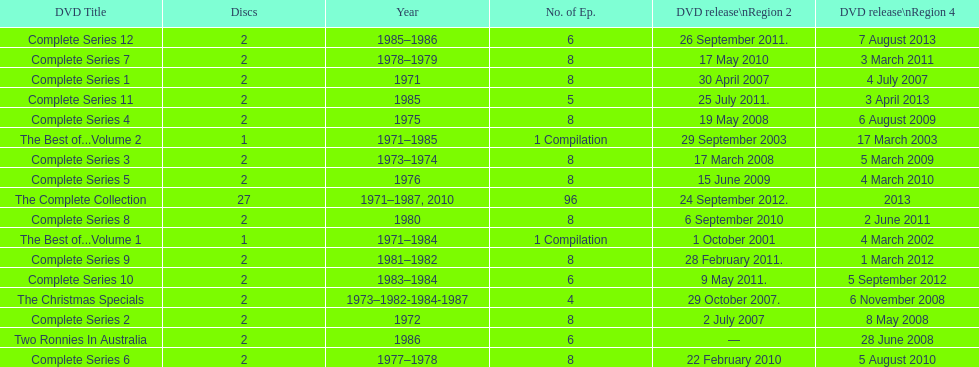What comes immediately after complete series 11? Complete Series 12. 